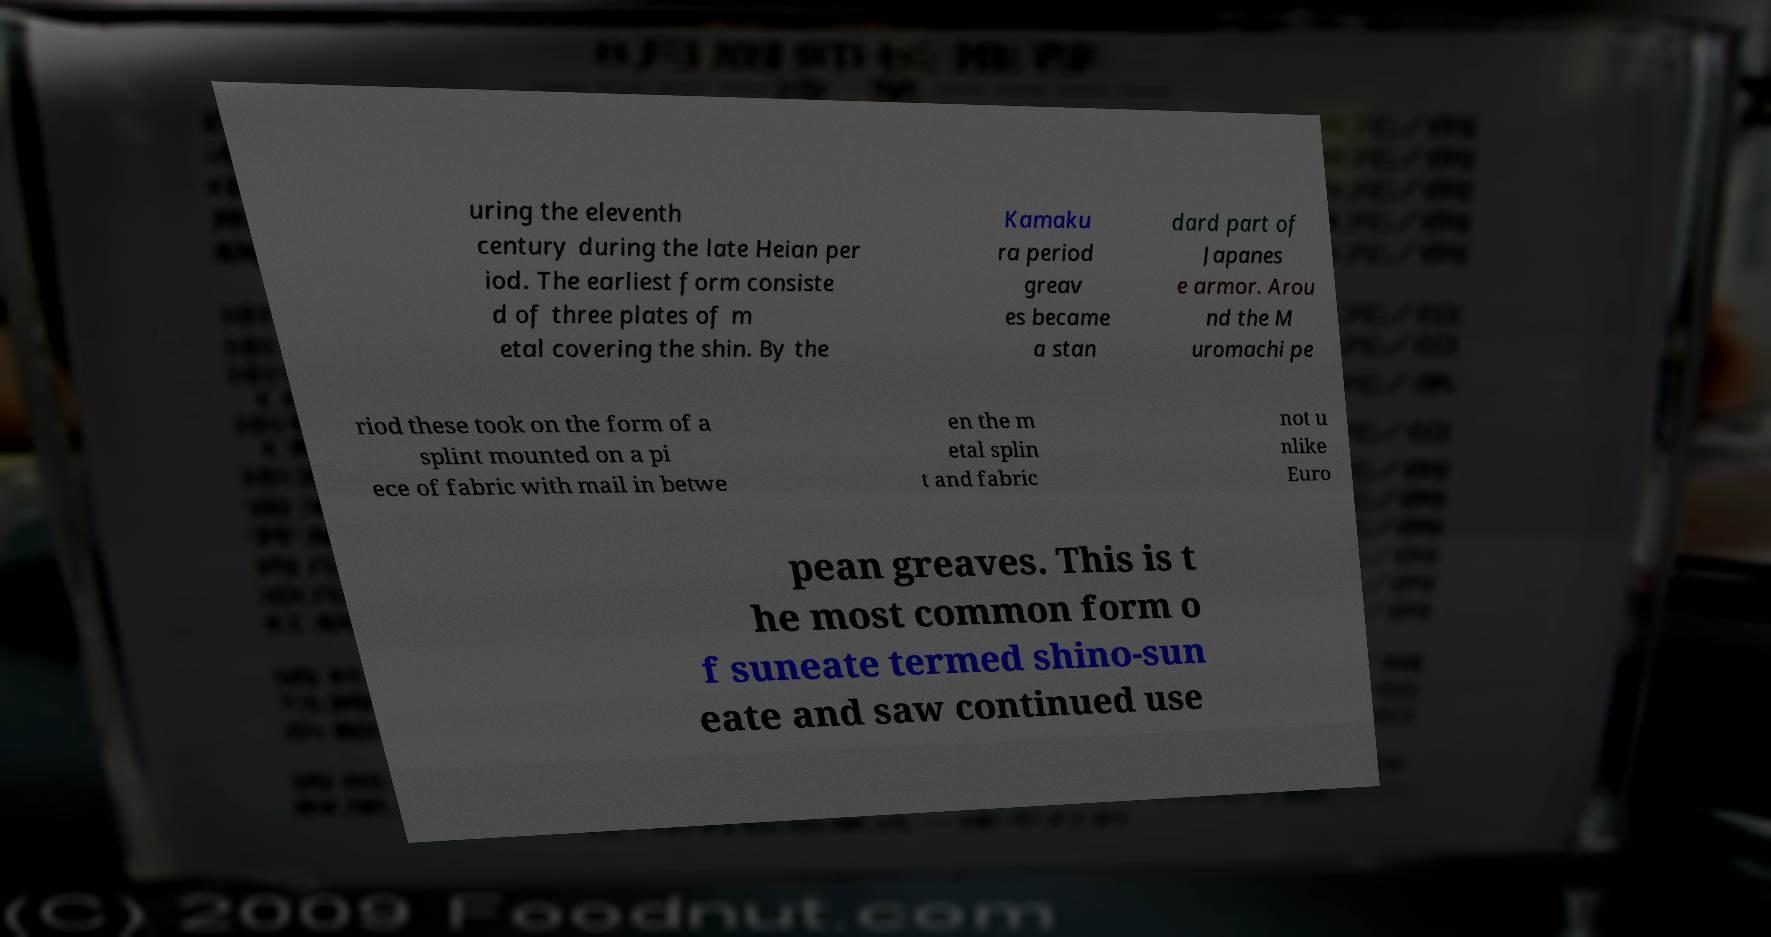There's text embedded in this image that I need extracted. Can you transcribe it verbatim? uring the eleventh century during the late Heian per iod. The earliest form consiste d of three plates of m etal covering the shin. By the Kamaku ra period greav es became a stan dard part of Japanes e armor. Arou nd the M uromachi pe riod these took on the form of a splint mounted on a pi ece of fabric with mail in betwe en the m etal splin t and fabric not u nlike Euro pean greaves. This is t he most common form o f suneate termed shino-sun eate and saw continued use 